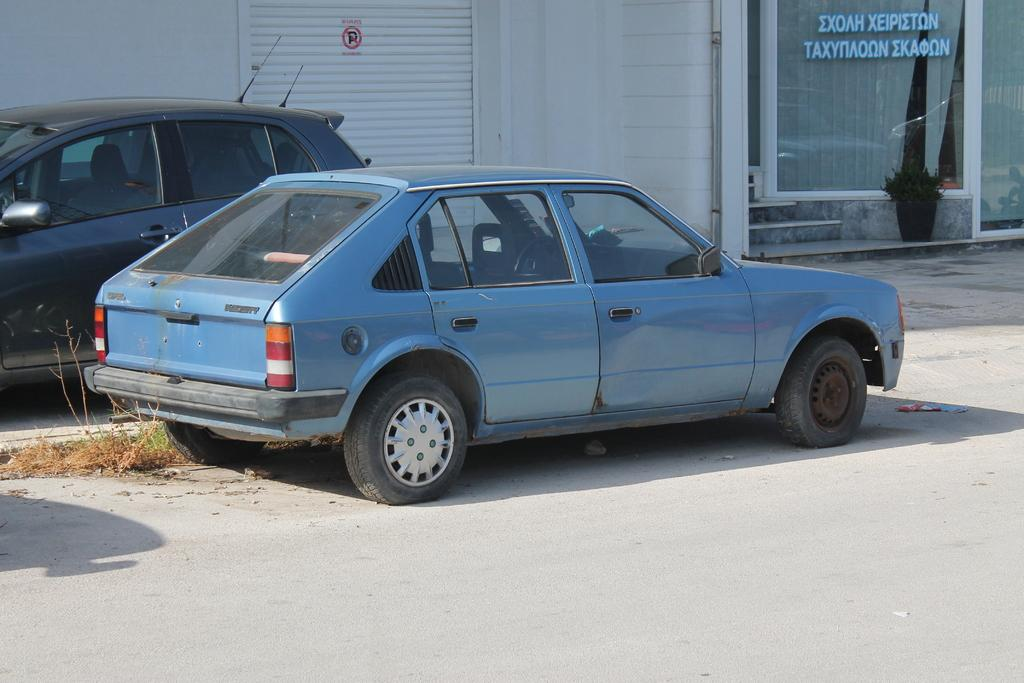How many cars are visible in the image? There are two cars on the ground in the image. What is located beside the cars? There are plants beside the cars. What is on the shutter in the image? There is a sign on the shutter in the image. What is the background of the image made of? There is a wall in the image. What is written on the glass in the image? There is some text on the glass in the image. What type of window treatment is present in the image? There are curtains in the image. What type of plant is inside the house in the image? There is a houseplant in the image. What architectural feature is present in the image? There are steps in the image. What type of attack is being carried out by the carriage in the image? There is no carriage present in the image, and therefore no attack can be observed. 